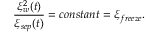Convert formula to latex. <formula><loc_0><loc_0><loc_500><loc_500>\frac { \xi _ { w } ^ { 2 } ( t ) } { \xi _ { s e p } ( t ) } = c o n s t a n t = \xi _ { f r e e z e } .</formula> 